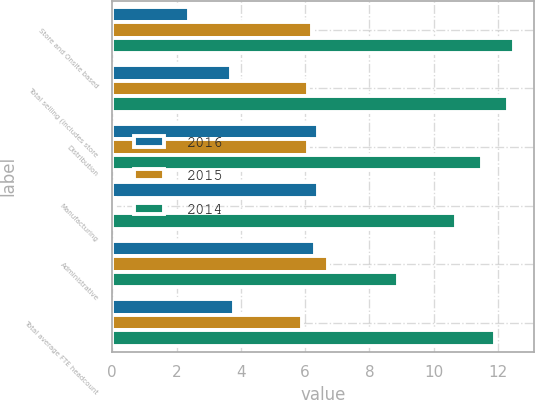Convert chart. <chart><loc_0><loc_0><loc_500><loc_500><stacked_bar_chart><ecel><fcel>Store and Onsite based<fcel>Total selling (includes store<fcel>Distribution<fcel>Manufacturing<fcel>Administrative<fcel>Total average FTE headcount<nl><fcel>2016<fcel>2.4<fcel>3.7<fcel>6.4<fcel>6.4<fcel>6.3<fcel>3.8<nl><fcel>2015<fcel>6.2<fcel>6.1<fcel>6.1<fcel>0.1<fcel>6.7<fcel>5.9<nl><fcel>2014<fcel>12.5<fcel>12.3<fcel>11.5<fcel>10.7<fcel>8.9<fcel>11.9<nl></chart> 